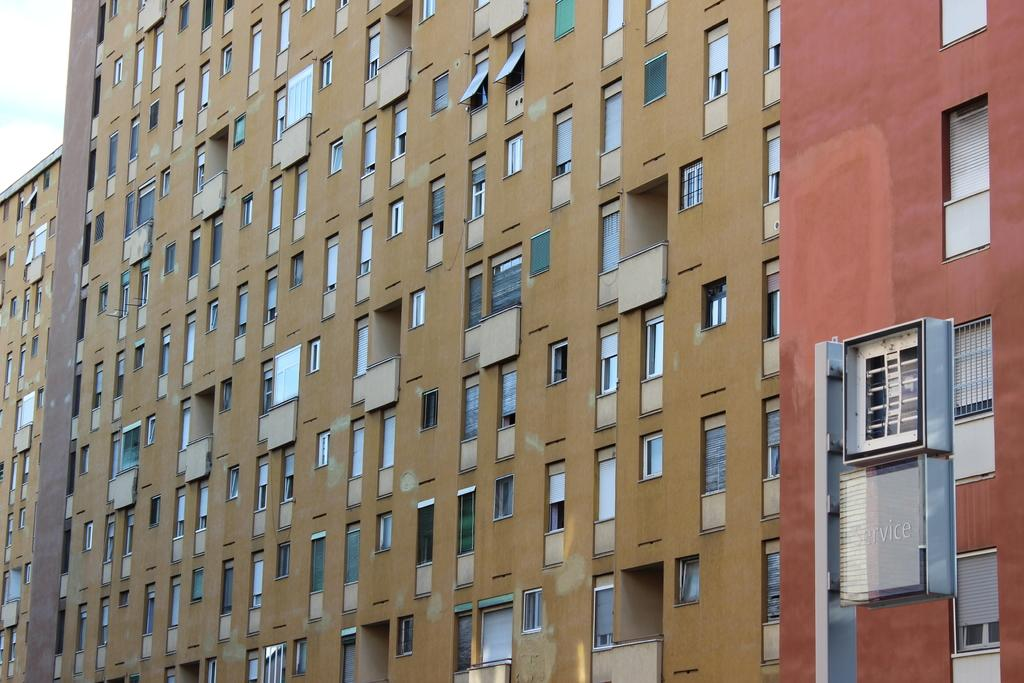What is the main subject in the middle of the image? There is a building in the middle of the image. What features can be observed on the building? The building has many windows and glass elements. What is written or displayed at the bottom of the image? There is text at the bottom of the image. What can be seen in the background of the image? The sky and clouds are visible in the background of the image. What part of the building is causing the clouds to form in the image? There is no specific part of the building causing the clouds to form in the image. Clouds are a natural weather phenomenon and are not directly influenced by the building. 